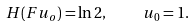Convert formula to latex. <formula><loc_0><loc_0><loc_500><loc_500>H ( F u _ { o } ) = \ln 2 , \quad u _ { 0 } = 1 .</formula> 